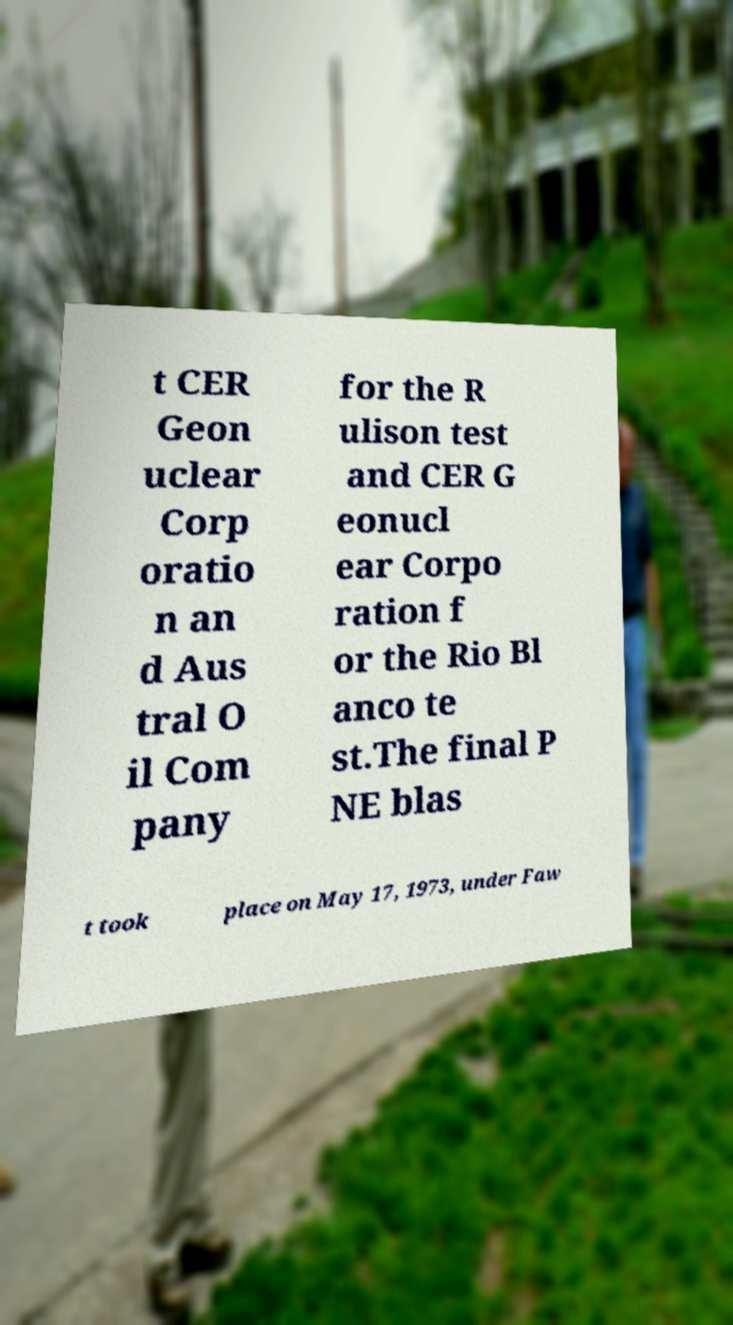Please identify and transcribe the text found in this image. t CER Geon uclear Corp oratio n an d Aus tral O il Com pany for the R ulison test and CER G eonucl ear Corpo ration f or the Rio Bl anco te st.The final P NE blas t took place on May 17, 1973, under Faw 